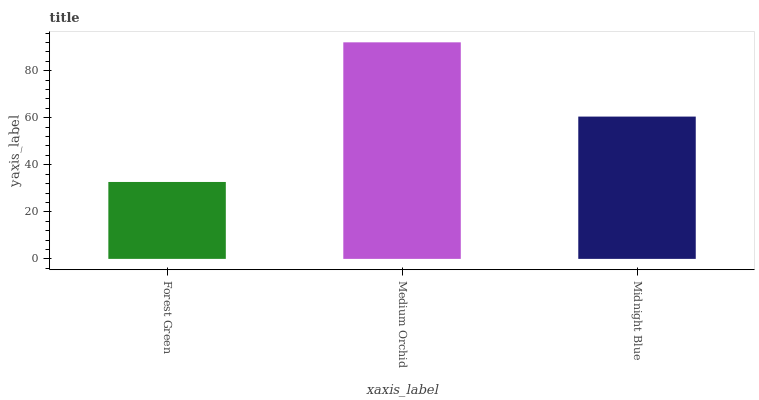Is Forest Green the minimum?
Answer yes or no. Yes. Is Medium Orchid the maximum?
Answer yes or no. Yes. Is Midnight Blue the minimum?
Answer yes or no. No. Is Midnight Blue the maximum?
Answer yes or no. No. Is Medium Orchid greater than Midnight Blue?
Answer yes or no. Yes. Is Midnight Blue less than Medium Orchid?
Answer yes or no. Yes. Is Midnight Blue greater than Medium Orchid?
Answer yes or no. No. Is Medium Orchid less than Midnight Blue?
Answer yes or no. No. Is Midnight Blue the high median?
Answer yes or no. Yes. Is Midnight Blue the low median?
Answer yes or no. Yes. Is Forest Green the high median?
Answer yes or no. No. Is Forest Green the low median?
Answer yes or no. No. 